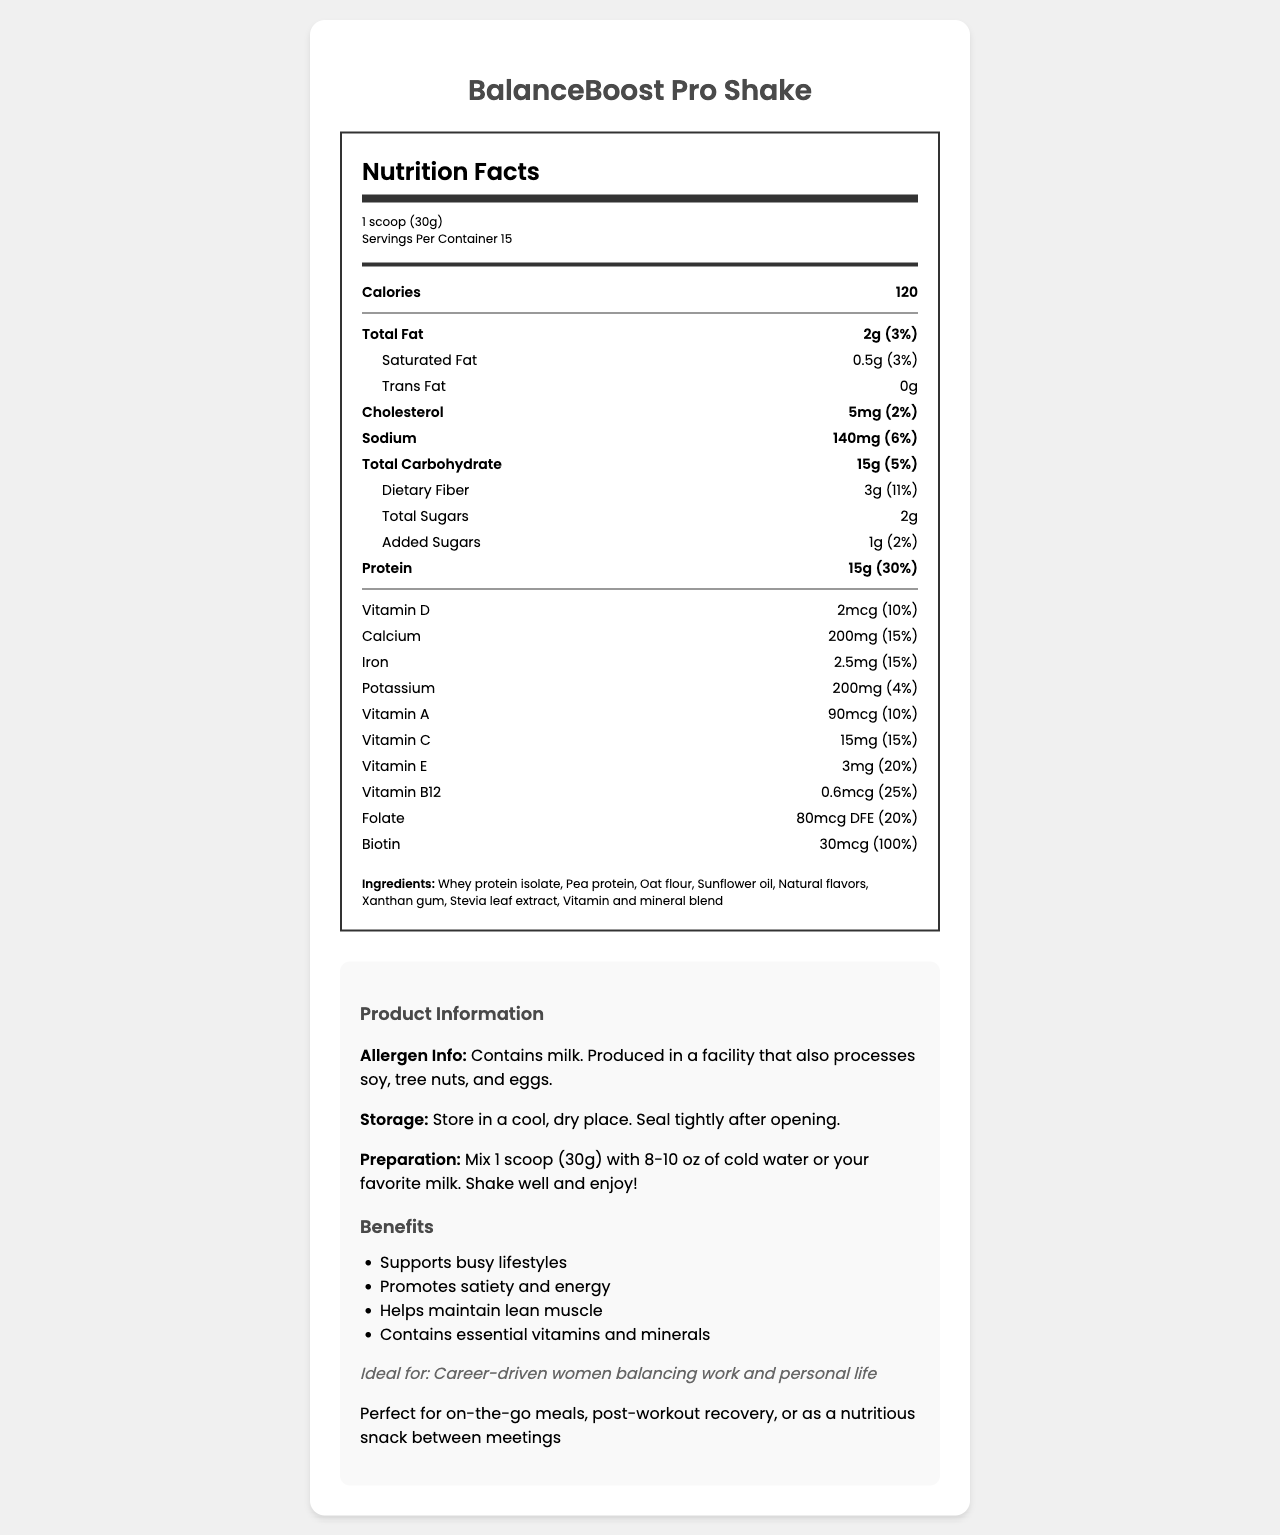what is the name of the product? The document title and introductory section clearly state the name of the product as "BalanceBoost Pro Shake."
Answer: BalanceBoost Pro Shake how many calories are in one serving? According to the Nutrition Facts section, one serving has 120 calories.
Answer: 120 what is the serving size? The document specifies the serving size as "1 scoop (30g)."
Answer: 1 scoop (30g) how much protein is in one serving? The Nutrition Facts label indicates that each serving contains 15 grams of protein.
Answer: 15g which vitamins are specifically listed in the document? The Nutrition Facts label lists these vitamins along with their amounts and daily values.
Answer: Vitamin D, Calcium, Iron, Potassium, Vitamin A, Vitamin C, Vitamin E, Vitamin B12, Folate, Biotin what is the percentage daily value for dietary fiber? The document indicates that the percentage daily value for dietary fiber is 11%.
Answer: 11% which ingredient is listed first? The ingredients list starts with "Whey protein isolate."
Answer: Whey protein isolate are there any trans fats in the product? The Nutrition Facts label states that there are 0 grams of trans fat.
Answer: No how should this shake be stored? The storage instructions specify to store the product in a cool, dry place and to seal it tightly after opening.
Answer: Store in a cool, dry place. Seal tightly after opening. how many servings are there per container? The Nutrition Facts label states there are 15 servings per container.
Answer: 15 which of the following benefits are associated with the product? A. Supports busy lifestyles B. Promotes digestion C. Helps maintain lean muscle Based on the product benefits listed, options A (Supports busy lifestyles) and C (Helps maintain lean muscle) are correct.
Answer: A and C what is the amount of added sugars? A. 1g B. 2g C. 3g The document specifies the amount of added sugars as 1 gram.
Answer: A is this product suitable for individuals with soy allergies? The allergen info mentions that this product is produced in a facility that also processes soy, so it might not be suitable for individuals with soy allergies.
Answer: No summarize the main idea of the entire document. The document provides comprehensive information about the BalanceBoost Pro Shake, including its nutritional content, benefits, instructions, and target audience.
Answer: The BalanceBoost Pro Shake is a meal replacement shake designed for busy professionals, particularly career-driven women balancing work and personal life. It contains essential nutrients, supports satiety and energy, helps maintain lean muscle, and is convenient for on-the-go meals or post-workout recovery. The Nutrition Facts label, ingredient list, allergen information, storage and preparation instructions, and product benefits are all provided. how many grams of total carbohydrate does one serving contain? The Nutrition Facts section states that each serving contains 15 grams of total carbohydrates.
Answer: 15g does the product contain any tree nuts? The allergen information mentions that the product is produced in a facility that processes tree nuts, but it does not specify whether the product itself contains tree nuts.
Answer: Cannot be determined 